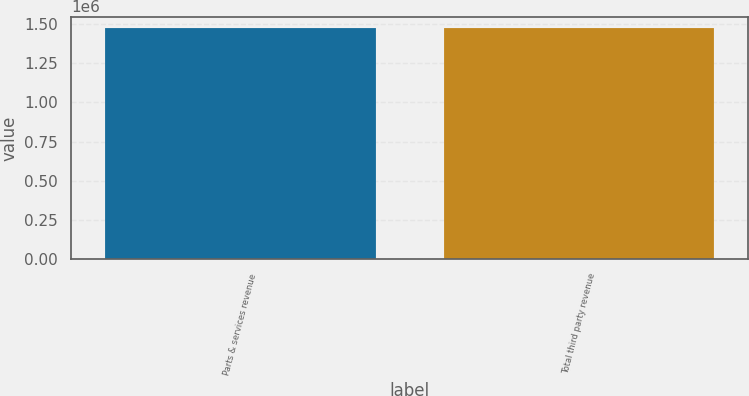<chart> <loc_0><loc_0><loc_500><loc_500><bar_chart><fcel>Parts & services revenue<fcel>Total third party revenue<nl><fcel>1.47296e+06<fcel>1.47296e+06<nl></chart> 